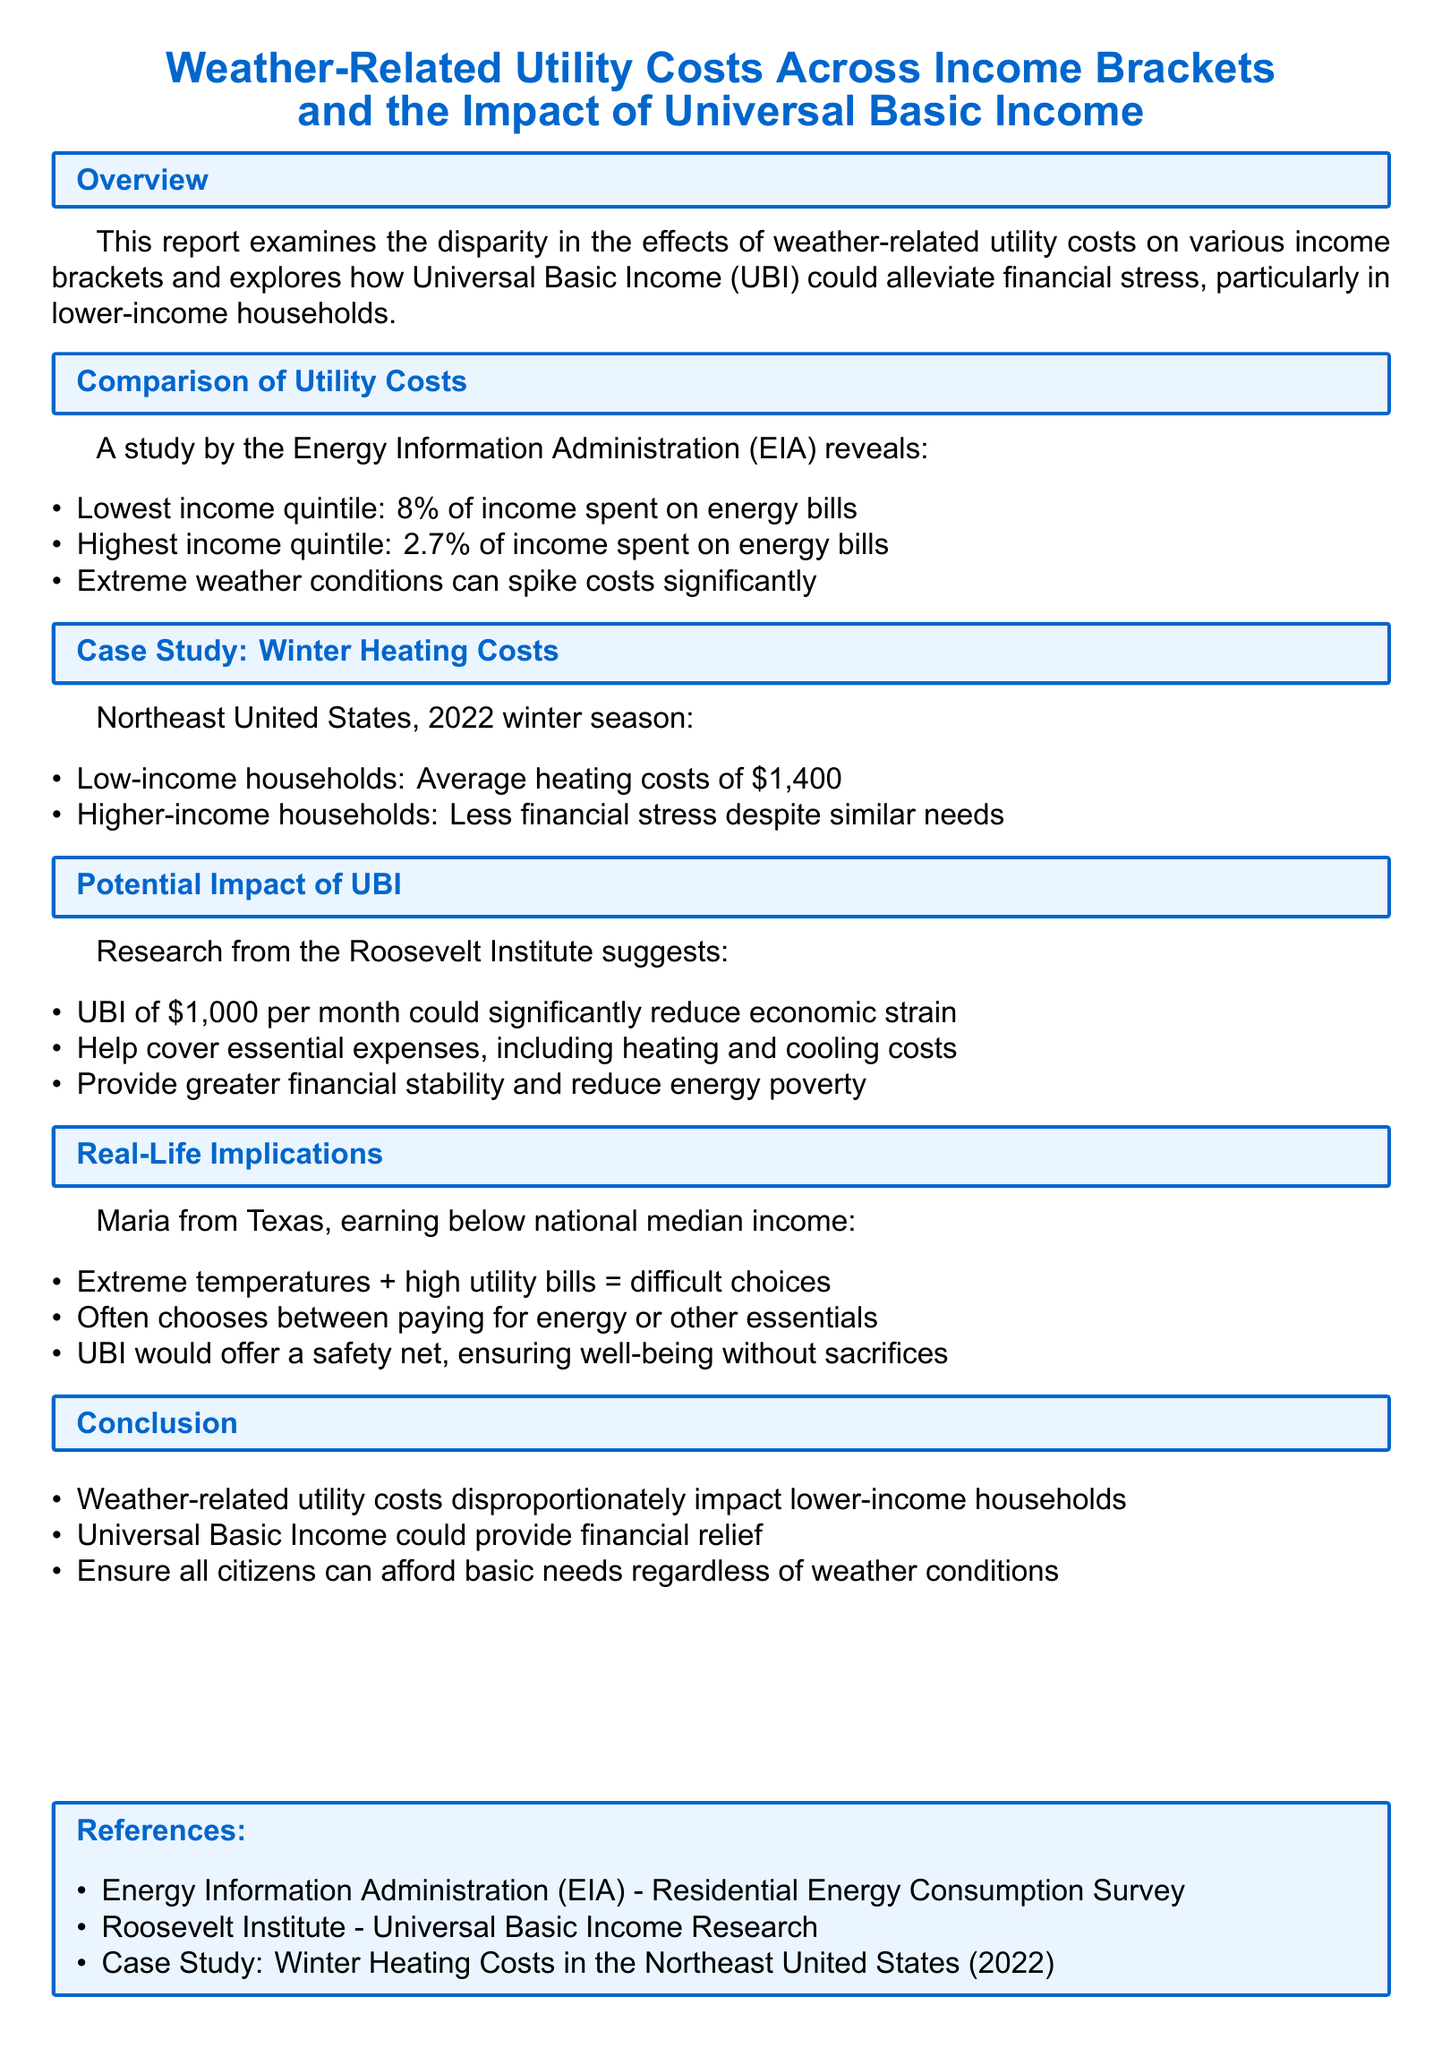What percentage of income do the lowest income quintile spend on energy bills? The document states that the lowest income quintile spends 8% of their income on energy bills.
Answer: 8% What is the average heating cost for low-income households in the Northeast during the 2022 winter season? According to the case study, low-income households had average heating costs of $1,400.
Answer: $1,400 What UBI amount is suggested by the Roosevelt Institute to reduce economic strain? The document mentions a UBI of $1,000 per month could significantly reduce economic strain.
Answer: $1,000 Who is cited as an example of someone facing financial stress due to utility costs? Maria from Texas is mentioned as an example experiencing difficulty in paying for energy bills.
Answer: Maria What is one potential benefit of UBI according to the report? The report suggests that UBI could provide greater financial stability and reduce energy poverty.
Answer: Financial stability 